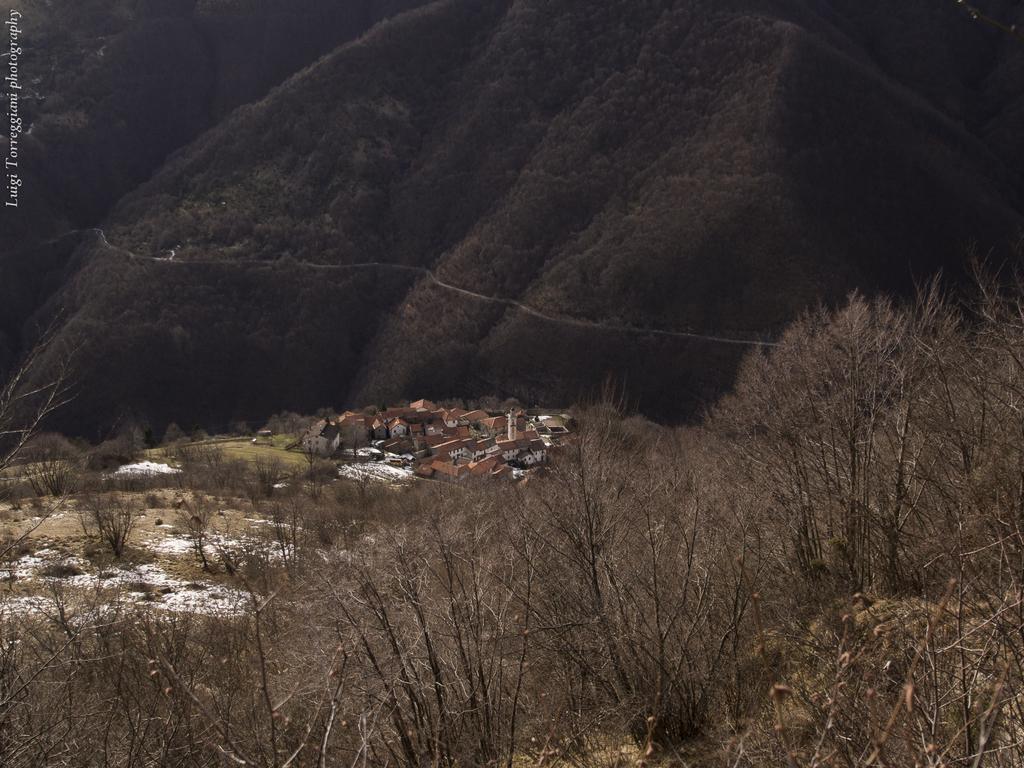Can you describe this image briefly? In this image in the front there are dry trees. In the center there are houses. In the background there are mountains and there is a grass in the center. 